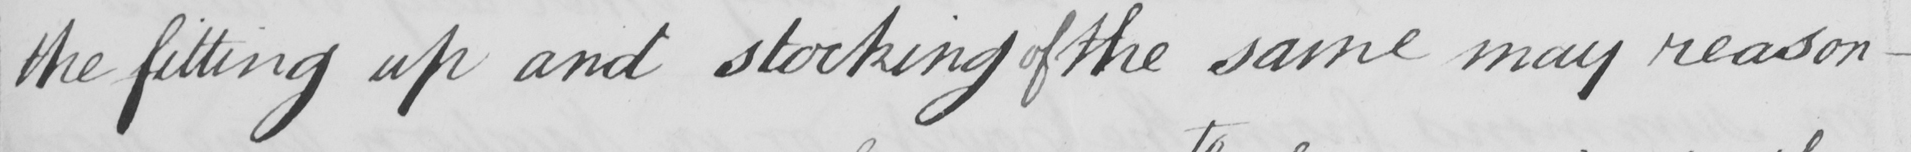What text is written in this handwritten line? the fitting up and stocking of the same may reason- 